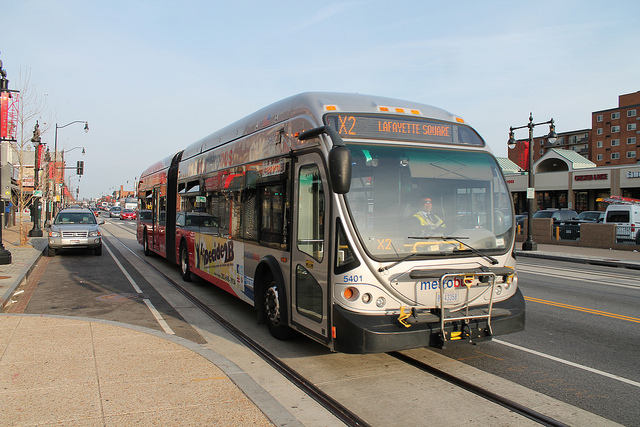Can you elaborate on the surroundings of the bus? The bus is travelling on a city street that includes both vehicular lanes and dedicated tracks for trams or trolleys, as indicated by the rail lines embedded in the road surface. There are commercial buildings along the street, and we can see various signs and business storefronts, suggesting a busy urban area with mixed traffic and commercial activities. Is there any other notable transportation in the image? Apart from the city bus, there's a vehicle following behind it, and farther back, another transit bus can be observed. This indicates a well-utilized public transportation system in operation along this corridor. 